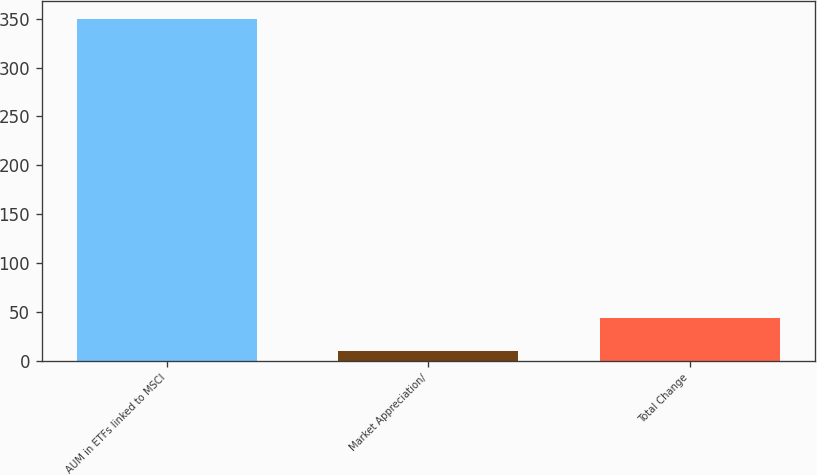Convert chart to OTSL. <chart><loc_0><loc_0><loc_500><loc_500><bar_chart><fcel>AUM in ETFs linked to MSCI<fcel>Market Appreciation/<fcel>Total Change<nl><fcel>350.1<fcel>10.1<fcel>44.1<nl></chart> 